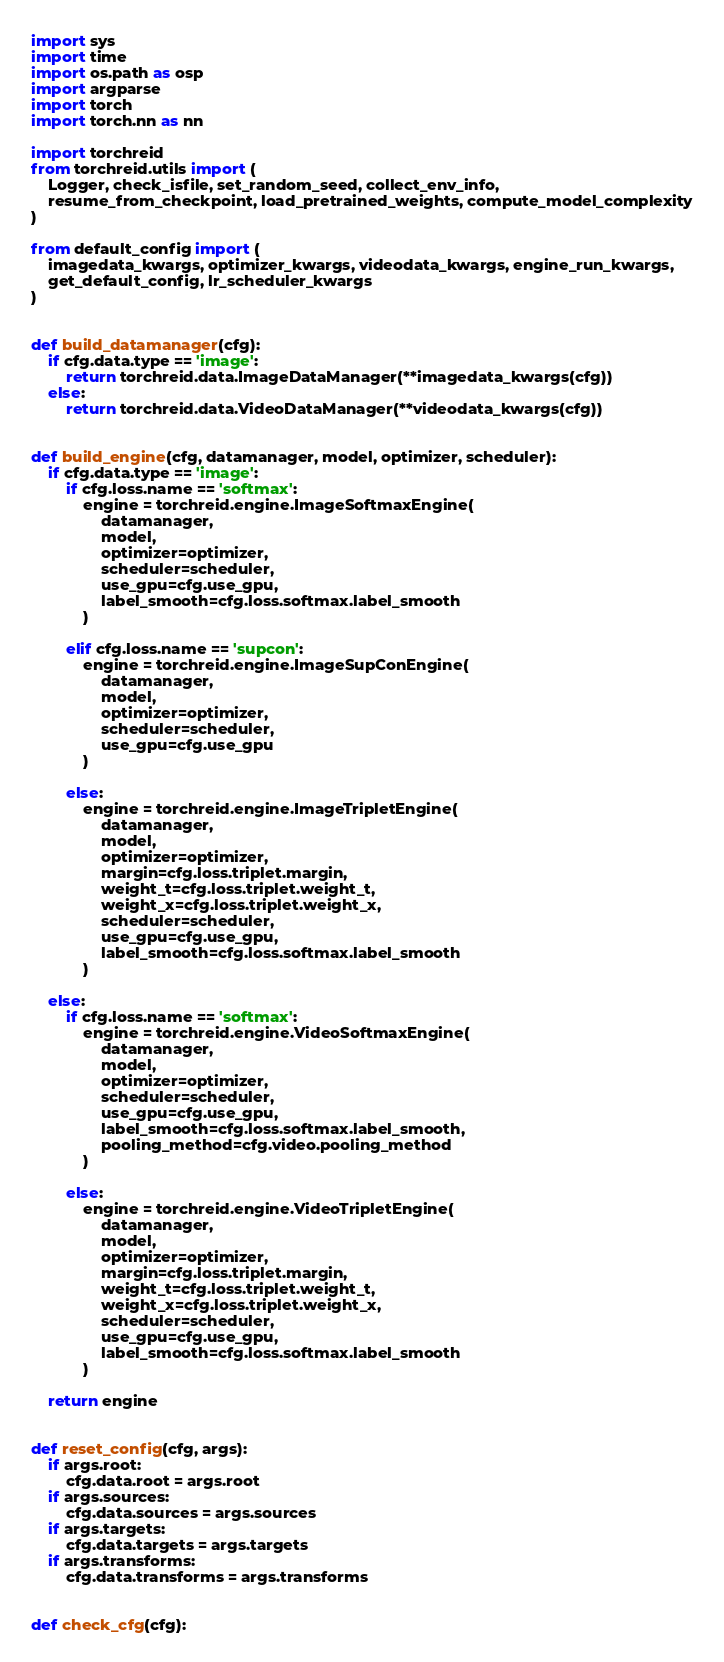<code> <loc_0><loc_0><loc_500><loc_500><_Python_>import sys
import time
import os.path as osp
import argparse
import torch
import torch.nn as nn

import torchreid
from torchreid.utils import (
    Logger, check_isfile, set_random_seed, collect_env_info,
    resume_from_checkpoint, load_pretrained_weights, compute_model_complexity
)

from default_config import (
    imagedata_kwargs, optimizer_kwargs, videodata_kwargs, engine_run_kwargs,
    get_default_config, lr_scheduler_kwargs
)


def build_datamanager(cfg):
    if cfg.data.type == 'image':
        return torchreid.data.ImageDataManager(**imagedata_kwargs(cfg))
    else:
        return torchreid.data.VideoDataManager(**videodata_kwargs(cfg))


def build_engine(cfg, datamanager, model, optimizer, scheduler):
    if cfg.data.type == 'image':
        if cfg.loss.name == 'softmax':
            engine = torchreid.engine.ImageSoftmaxEngine(
                datamanager,
                model,
                optimizer=optimizer,
                scheduler=scheduler,
                use_gpu=cfg.use_gpu,
                label_smooth=cfg.loss.softmax.label_smooth
            )

        elif cfg.loss.name == 'supcon':
            engine = torchreid.engine.ImageSupConEngine(
                datamanager,
                model,
                optimizer=optimizer,
                scheduler=scheduler,
                use_gpu=cfg.use_gpu
            )

        else:
            engine = torchreid.engine.ImageTripletEngine(
                datamanager,
                model,
                optimizer=optimizer,
                margin=cfg.loss.triplet.margin,
                weight_t=cfg.loss.triplet.weight_t,
                weight_x=cfg.loss.triplet.weight_x,
                scheduler=scheduler,
                use_gpu=cfg.use_gpu,
                label_smooth=cfg.loss.softmax.label_smooth
            )

    else:
        if cfg.loss.name == 'softmax':
            engine = torchreid.engine.VideoSoftmaxEngine(
                datamanager,
                model,
                optimizer=optimizer,
                scheduler=scheduler,
                use_gpu=cfg.use_gpu,
                label_smooth=cfg.loss.softmax.label_smooth,
                pooling_method=cfg.video.pooling_method
            )

        else:
            engine = torchreid.engine.VideoTripletEngine(
                datamanager,
                model,
                optimizer=optimizer,
                margin=cfg.loss.triplet.margin,
                weight_t=cfg.loss.triplet.weight_t,
                weight_x=cfg.loss.triplet.weight_x,
                scheduler=scheduler,
                use_gpu=cfg.use_gpu,
                label_smooth=cfg.loss.softmax.label_smooth
            )

    return engine


def reset_config(cfg, args):
    if args.root:
        cfg.data.root = args.root
    if args.sources:
        cfg.data.sources = args.sources
    if args.targets:
        cfg.data.targets = args.targets
    if args.transforms:
        cfg.data.transforms = args.transforms


def check_cfg(cfg):</code> 